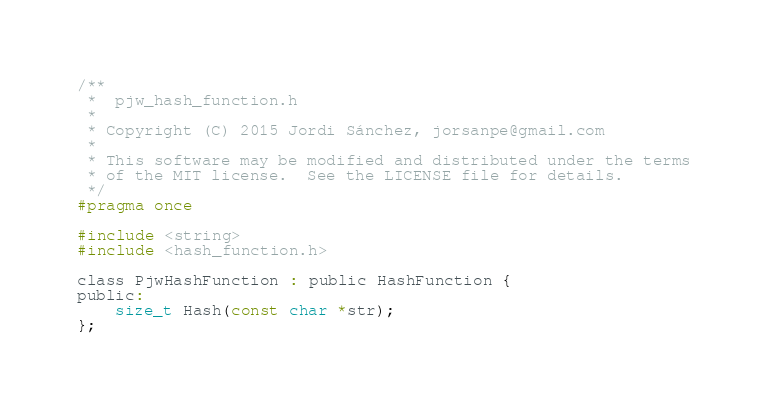<code> <loc_0><loc_0><loc_500><loc_500><_C_>/**
 *  pjw_hash_function.h
 *
 * Copyright (C) 2015 Jordi Sánchez, jorsanpe@gmail.com
 *
 * This software may be modified and distributed under the terms
 * of the MIT license.  See the LICENSE file for details.
 */
#pragma once

#include <string>
#include <hash_function.h>

class PjwHashFunction : public HashFunction {
public:
    size_t Hash(const char *str);
};
</code> 